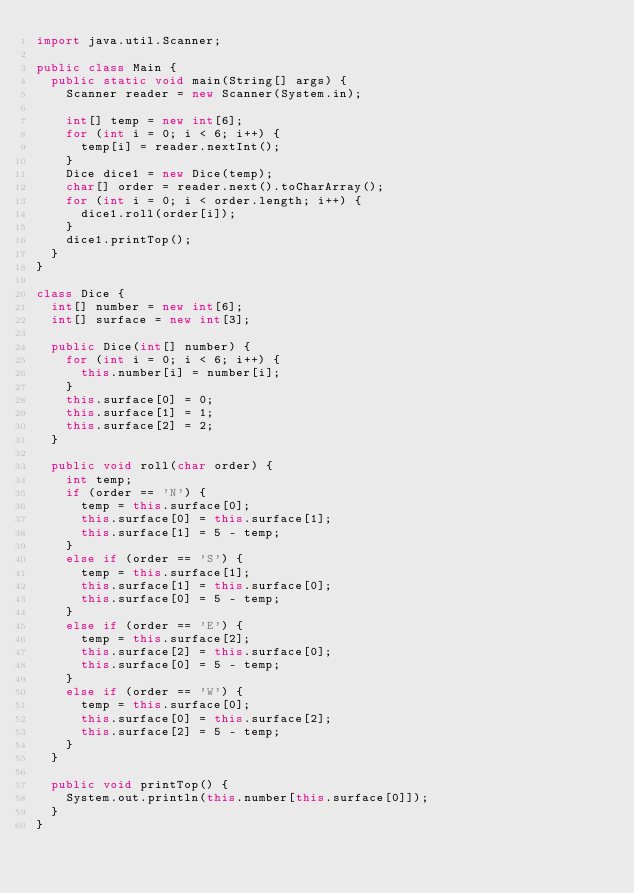<code> <loc_0><loc_0><loc_500><loc_500><_Java_>import java.util.Scanner;

public class Main {
  public static void main(String[] args) {
    Scanner reader = new Scanner(System.in);

    int[] temp = new int[6];
    for (int i = 0; i < 6; i++) {
      temp[i] = reader.nextInt();
    }
    Dice dice1 = new Dice(temp);
    char[] order = reader.next().toCharArray();
    for (int i = 0; i < order.length; i++) {
      dice1.roll(order[i]);
    }
    dice1.printTop();
  }
}

class Dice {
  int[] number = new int[6];
  int[] surface = new int[3];

  public Dice(int[] number) {
    for (int i = 0; i < 6; i++) {
      this.number[i] = number[i];
    }
    this.surface[0] = 0;
    this.surface[1] = 1;
    this.surface[2] = 2;
  }

  public void roll(char order) {
    int temp;
    if (order == 'N') {
      temp = this.surface[0];
      this.surface[0] = this.surface[1];
      this.surface[1] = 5 - temp;
    }
    else if (order == 'S') {
      temp = this.surface[1];
      this.surface[1] = this.surface[0];
      this.surface[0] = 5 - temp;
    }
    else if (order == 'E') {
      temp = this.surface[2];
      this.surface[2] = this.surface[0];
      this.surface[0] = 5 - temp;
    }
    else if (order == 'W') {
      temp = this.surface[0];
      this.surface[0] = this.surface[2];
      this.surface[2] = 5 - temp;
    }
  }

  public void printTop() {
    System.out.println(this.number[this.surface[0]]);
  }
}</code> 